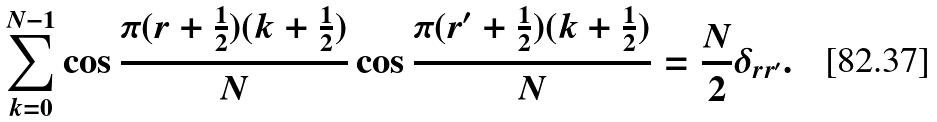Convert formula to latex. <formula><loc_0><loc_0><loc_500><loc_500>\sum _ { k = 0 } ^ { N - 1 } \cos \frac { \pi ( r + \frac { 1 } { 2 } ) ( k + \frac { 1 } { 2 } ) } N \cos \frac { \pi ( r ^ { \prime } + \frac { 1 } { 2 } ) ( k + \frac { 1 } { 2 } ) } N = \frac { N } { 2 } \delta _ { r r ^ { \prime } } .</formula> 